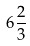Convert formula to latex. <formula><loc_0><loc_0><loc_500><loc_500>6 { \frac { 2 } { 3 } }</formula> 